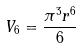<formula> <loc_0><loc_0><loc_500><loc_500>V _ { 6 } = \frac { \pi ^ { 3 } r ^ { 6 } } { 6 }</formula> 